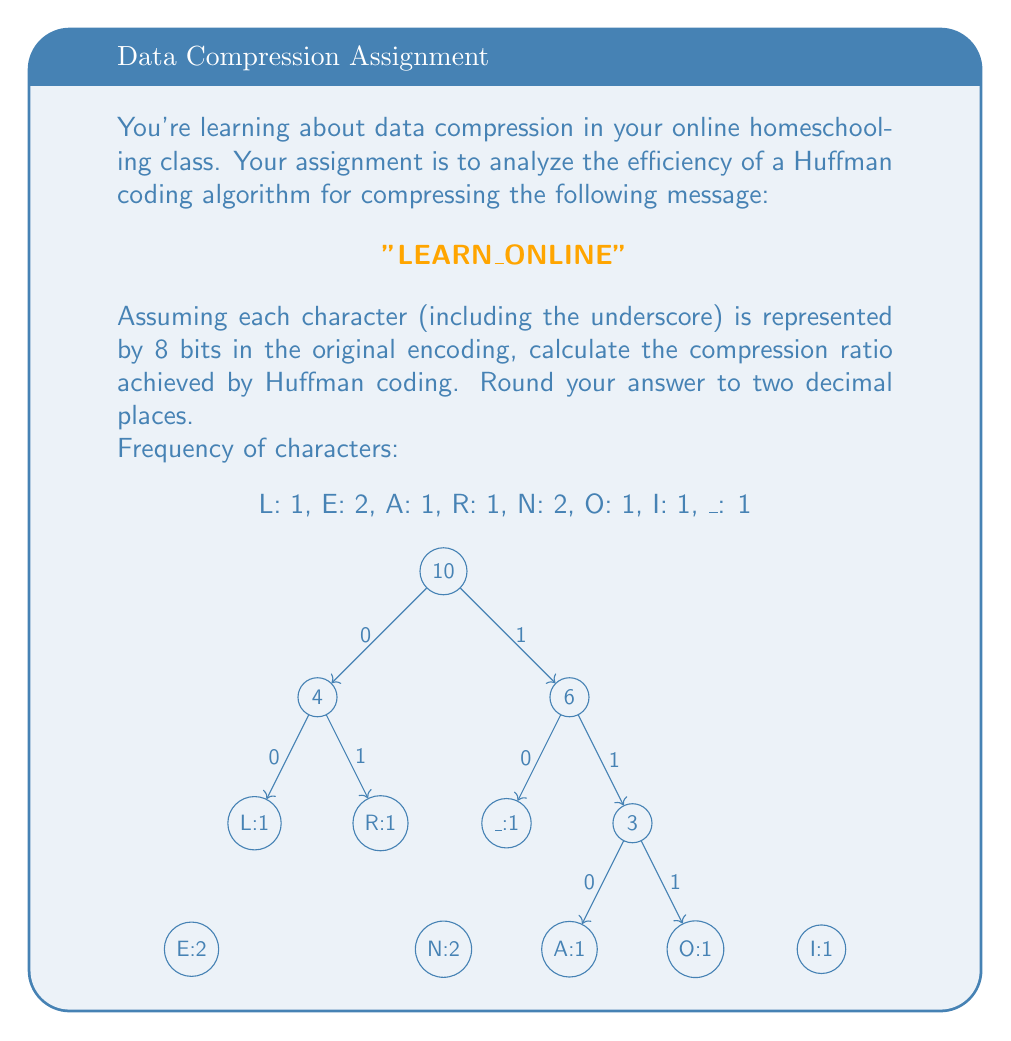What is the answer to this math problem? Let's approach this step-by-step:

1) First, we need to construct the Huffman tree based on the given frequencies. The tree is shown in the question.

2) From the tree, we can derive the Huffman codes for each character:
   L: 000, E: 001, A: 1100, R: 001, N: 01, O: 1101, I: 111, _: 100

3) Now, let's calculate the total bits needed for the Huffman-encoded message:
   L(000) + E(001) + A(1100) + R(001) + N(01) + _(100) + O(1101) + N(01) + L(000) + I(111) + N(01) + E(001)
   = 3 + 3 + 4 + 3 + 2 + 3 + 4 + 2 + 3 + 3 + 2 + 3 = 35 bits

4) In the original encoding, each character uses 8 bits:
   12 characters * 8 bits = 96 bits

5) The compression ratio is calculated as:
   $$ \text{Compression Ratio} = \frac{\text{Original Size}}{\text{Compressed Size}} $$

   $$ \text{Compression Ratio} = \frac{96}{35} \approx 2.74 $$

6) Rounding to two decimal places, we get 2.74.

This means that the Huffman-coded message takes up about 2.74 times less space than the original encoding.
Answer: 2.74 